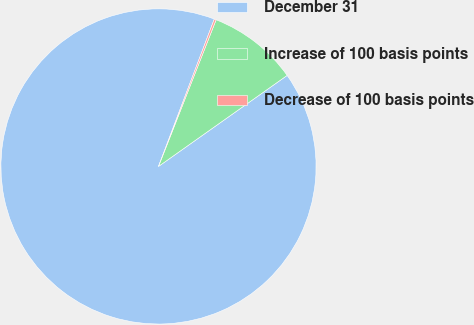Convert chart. <chart><loc_0><loc_0><loc_500><loc_500><pie_chart><fcel>December 31<fcel>Increase of 100 basis points<fcel>Decrease of 100 basis points<nl><fcel>90.56%<fcel>9.24%<fcel>0.2%<nl></chart> 